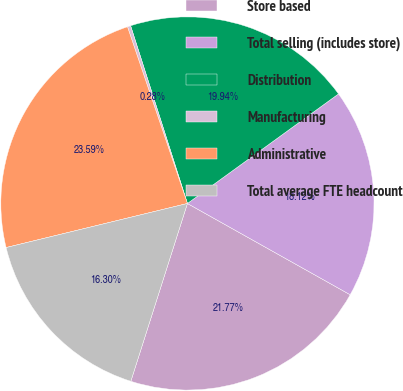<chart> <loc_0><loc_0><loc_500><loc_500><pie_chart><fcel>Store based<fcel>Total selling (includes store)<fcel>Distribution<fcel>Manufacturing<fcel>Administrative<fcel>Total average FTE headcount<nl><fcel>21.77%<fcel>18.12%<fcel>19.94%<fcel>0.28%<fcel>23.59%<fcel>16.3%<nl></chart> 